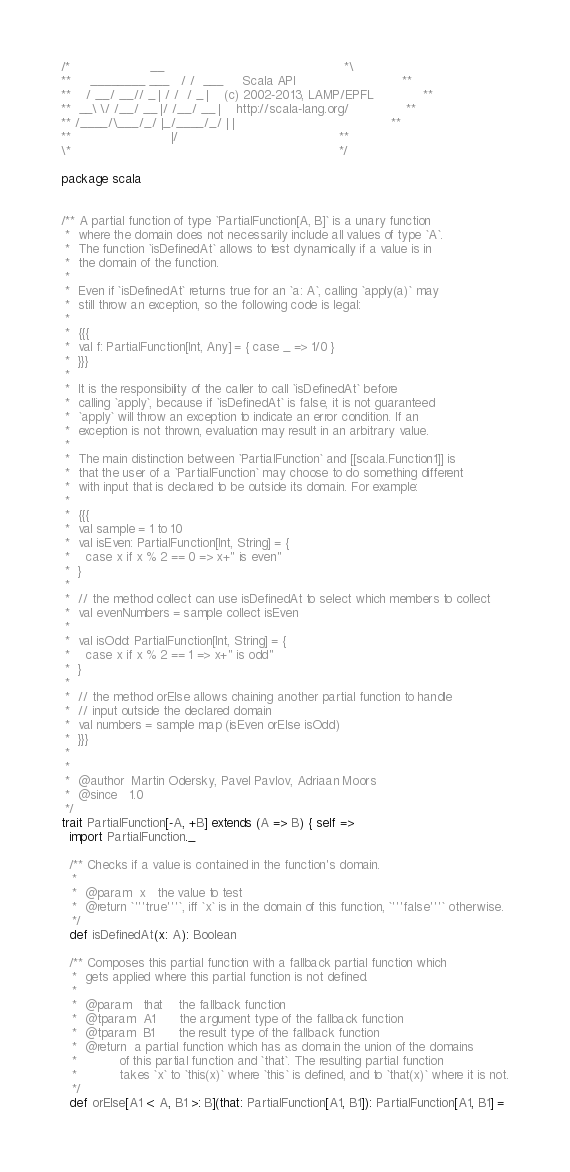<code> <loc_0><loc_0><loc_500><loc_500><_Scala_>/*                     __                                               *\
**     ________ ___   / /  ___     Scala API                            **
**    / __/ __// _ | / /  / _ |    (c) 2002-2013, LAMP/EPFL             **
**  __\ \/ /__/ __ |/ /__/ __ |    http://scala-lang.org/               **
** /____/\___/_/ |_/____/_/ | |                                         **
**                          |/                                          **
\*                                                                      */

package scala


/** A partial function of type `PartialFunction[A, B]` is a unary function
 *  where the domain does not necessarily include all values of type `A`.
 *  The function `isDefinedAt` allows to test dynamically if a value is in
 *  the domain of the function.
 *
 *  Even if `isDefinedAt` returns true for an `a: A`, calling `apply(a)` may
 *  still throw an exception, so the following code is legal:
 *
 *  {{{
 *  val f: PartialFunction[Int, Any] = { case _ => 1/0 }
 *  }}}
 *
 *  It is the responsibility of the caller to call `isDefinedAt` before
 *  calling `apply`, because if `isDefinedAt` is false, it is not guaranteed
 *  `apply` will throw an exception to indicate an error condition. If an
 *  exception is not thrown, evaluation may result in an arbitrary value.
 *
 *  The main distinction between `PartialFunction` and [[scala.Function1]] is
 *  that the user of a `PartialFunction` may choose to do something different
 *  with input that is declared to be outside its domain. For example:
 *
 *  {{{
 *  val sample = 1 to 10
 *  val isEven: PartialFunction[Int, String] = {
 *    case x if x % 2 == 0 => x+" is even"
 *  }
 *
 *  // the method collect can use isDefinedAt to select which members to collect
 *  val evenNumbers = sample collect isEven
 *
 *  val isOdd: PartialFunction[Int, String] = {
 *    case x if x % 2 == 1 => x+" is odd"
 *  }
 *
 *  // the method orElse allows chaining another partial function to handle
 *  // input outside the declared domain
 *  val numbers = sample map (isEven orElse isOdd)
 *  }}}
 *
 *
 *  @author  Martin Odersky, Pavel Pavlov, Adriaan Moors
 *  @since   1.0
 */
trait PartialFunction[-A, +B] extends (A => B) { self =>
  import PartialFunction._

  /** Checks if a value is contained in the function's domain.
   *
   *  @param  x   the value to test
   *  @return `'''true'''`, iff `x` is in the domain of this function, `'''false'''` otherwise.
   */
  def isDefinedAt(x: A): Boolean

  /** Composes this partial function with a fallback partial function which
   *  gets applied where this partial function is not defined.
   *
   *  @param   that    the fallback function
   *  @tparam  A1      the argument type of the fallback function
   *  @tparam  B1      the result type of the fallback function
   *  @return  a partial function which has as domain the union of the domains
   *           of this partial function and `that`. The resulting partial function
   *           takes `x` to `this(x)` where `this` is defined, and to `that(x)` where it is not.
   */
  def orElse[A1 <: A, B1 >: B](that: PartialFunction[A1, B1]): PartialFunction[A1, B1] =</code> 